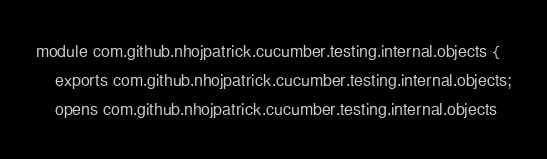<code> <loc_0><loc_0><loc_500><loc_500><_Java_>module com.github.nhojpatrick.cucumber.testing.internal.objects {
    exports com.github.nhojpatrick.cucumber.testing.internal.objects;
    opens com.github.nhojpatrick.cucumber.testing.internal.objects</code> 